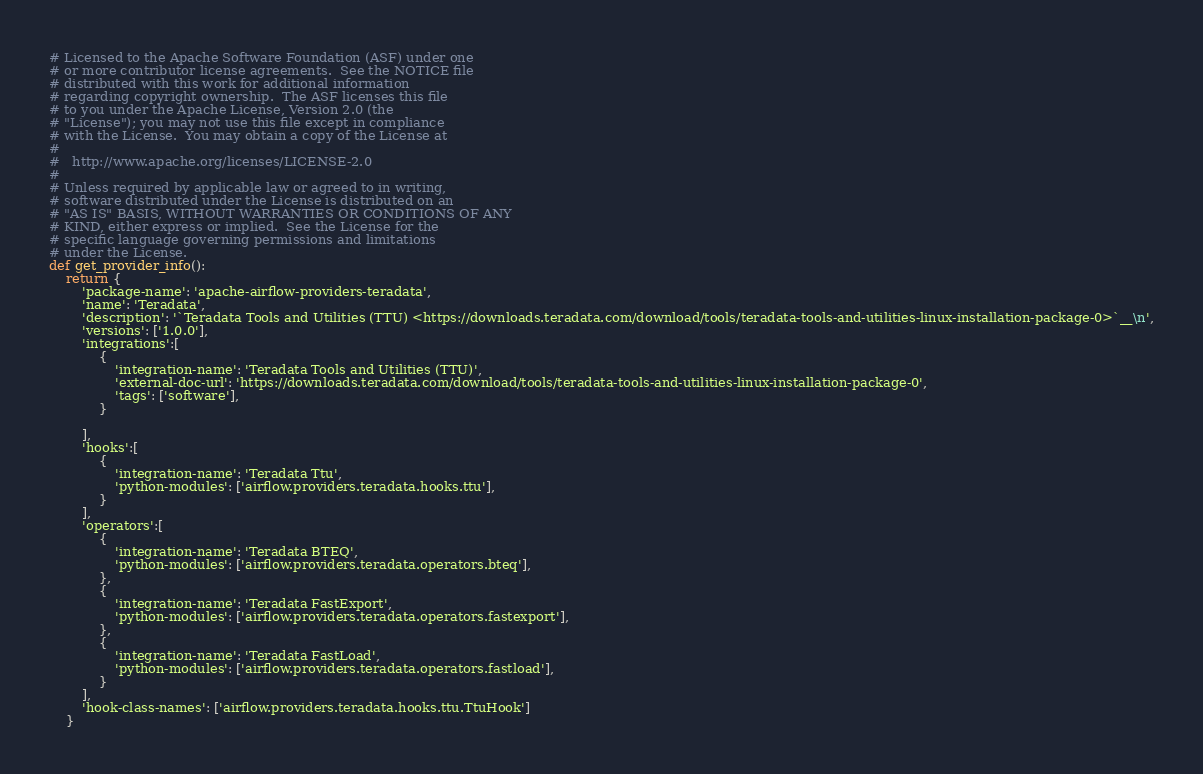<code> <loc_0><loc_0><loc_500><loc_500><_Python_># Licensed to the Apache Software Foundation (ASF) under one
# or more contributor license agreements.  See the NOTICE file
# distributed with this work for additional information
# regarding copyright ownership.  The ASF licenses this file
# to you under the Apache License, Version 2.0 (the
# "License"); you may not use this file except in compliance
# with the License.  You may obtain a copy of the License at
#
#   http://www.apache.org/licenses/LICENSE-2.0
#
# Unless required by applicable law or agreed to in writing,
# software distributed under the License is distributed on an
# "AS IS" BASIS, WITHOUT WARRANTIES OR CONDITIONS OF ANY
# KIND, either express or implied.  See the License for the
# specific language governing permissions and limitations
# under the License.
def get_provider_info():
    return {
        'package-name': 'apache-airflow-providers-teradata',
        'name': 'Teradata',
        'description': '`Teradata Tools and Utilities (TTU) <https://downloads.teradata.com/download/tools/teradata-tools-and-utilities-linux-installation-package-0>`__\n',
        'versions': ['1.0.0'],
        'integrations':[
            {
                'integration-name': 'Teradata Tools and Utilities (TTU)',
                'external-doc-url': 'https://downloads.teradata.com/download/tools/teradata-tools-and-utilities-linux-installation-package-0',
                'tags': ['software'],
            }

        ],
        'hooks':[
            {
                'integration-name': 'Teradata Ttu',
                'python-modules': ['airflow.providers.teradata.hooks.ttu'],
            }
        ],
        'operators':[
            {
                'integration-name': 'Teradata BTEQ',
                'python-modules': ['airflow.providers.teradata.operators.bteq'],
            },
            {
                'integration-name': 'Teradata FastExport',
                'python-modules': ['airflow.providers.teradata.operators.fastexport'],
            },
            {
                'integration-name': 'Teradata FastLoad',
                'python-modules': ['airflow.providers.teradata.operators.fastload'],
            }
        ],
        'hook-class-names': ['airflow.providers.teradata.hooks.ttu.TtuHook']
    }</code> 